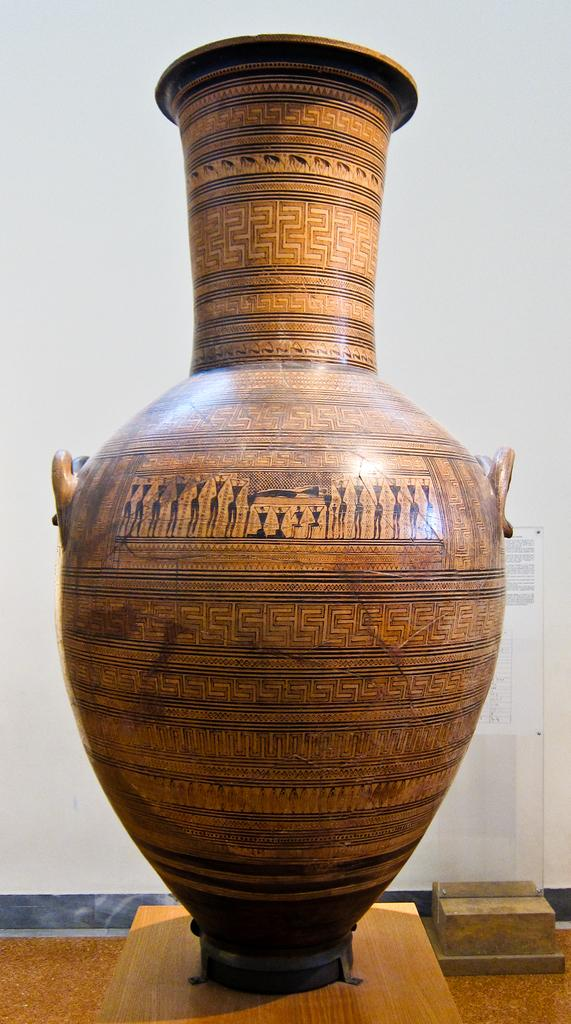What is the color of the spot visible on the wooden surface in the image? The spot is brown. What type of surface does the brown spot appear on? The brown spot is on a wooden surface. What color is the background of the image? The background of the image is white. How many robins can be seen flying over the ocean in the image? There are no robins or ocean present in the image; it only features a brown spot on a wooden surface with a white background. 